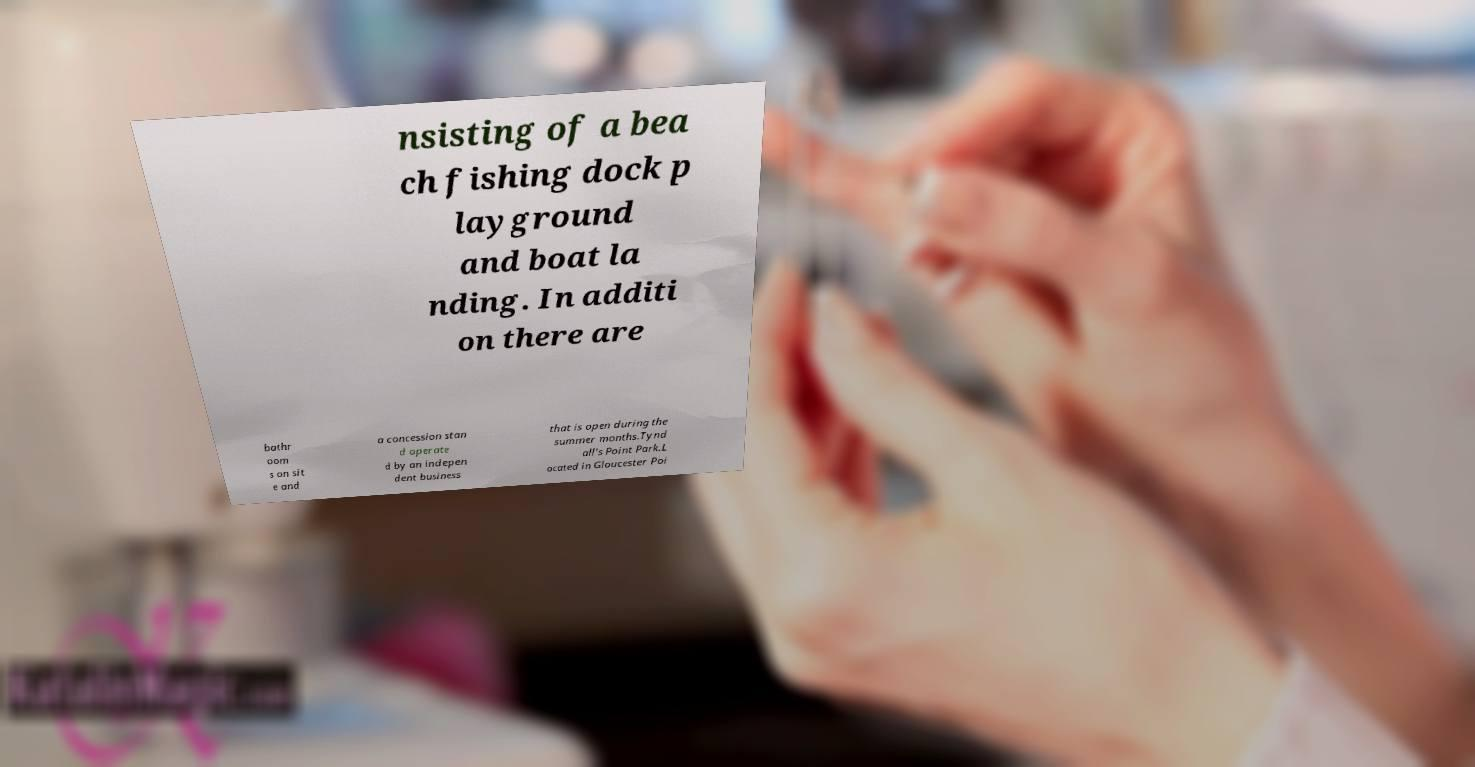I need the written content from this picture converted into text. Can you do that? nsisting of a bea ch fishing dock p layground and boat la nding. In additi on there are bathr oom s on sit e and a concession stan d operate d by an indepen dent business that is open during the summer months.Tynd all's Point Park.L ocated in Gloucester Poi 